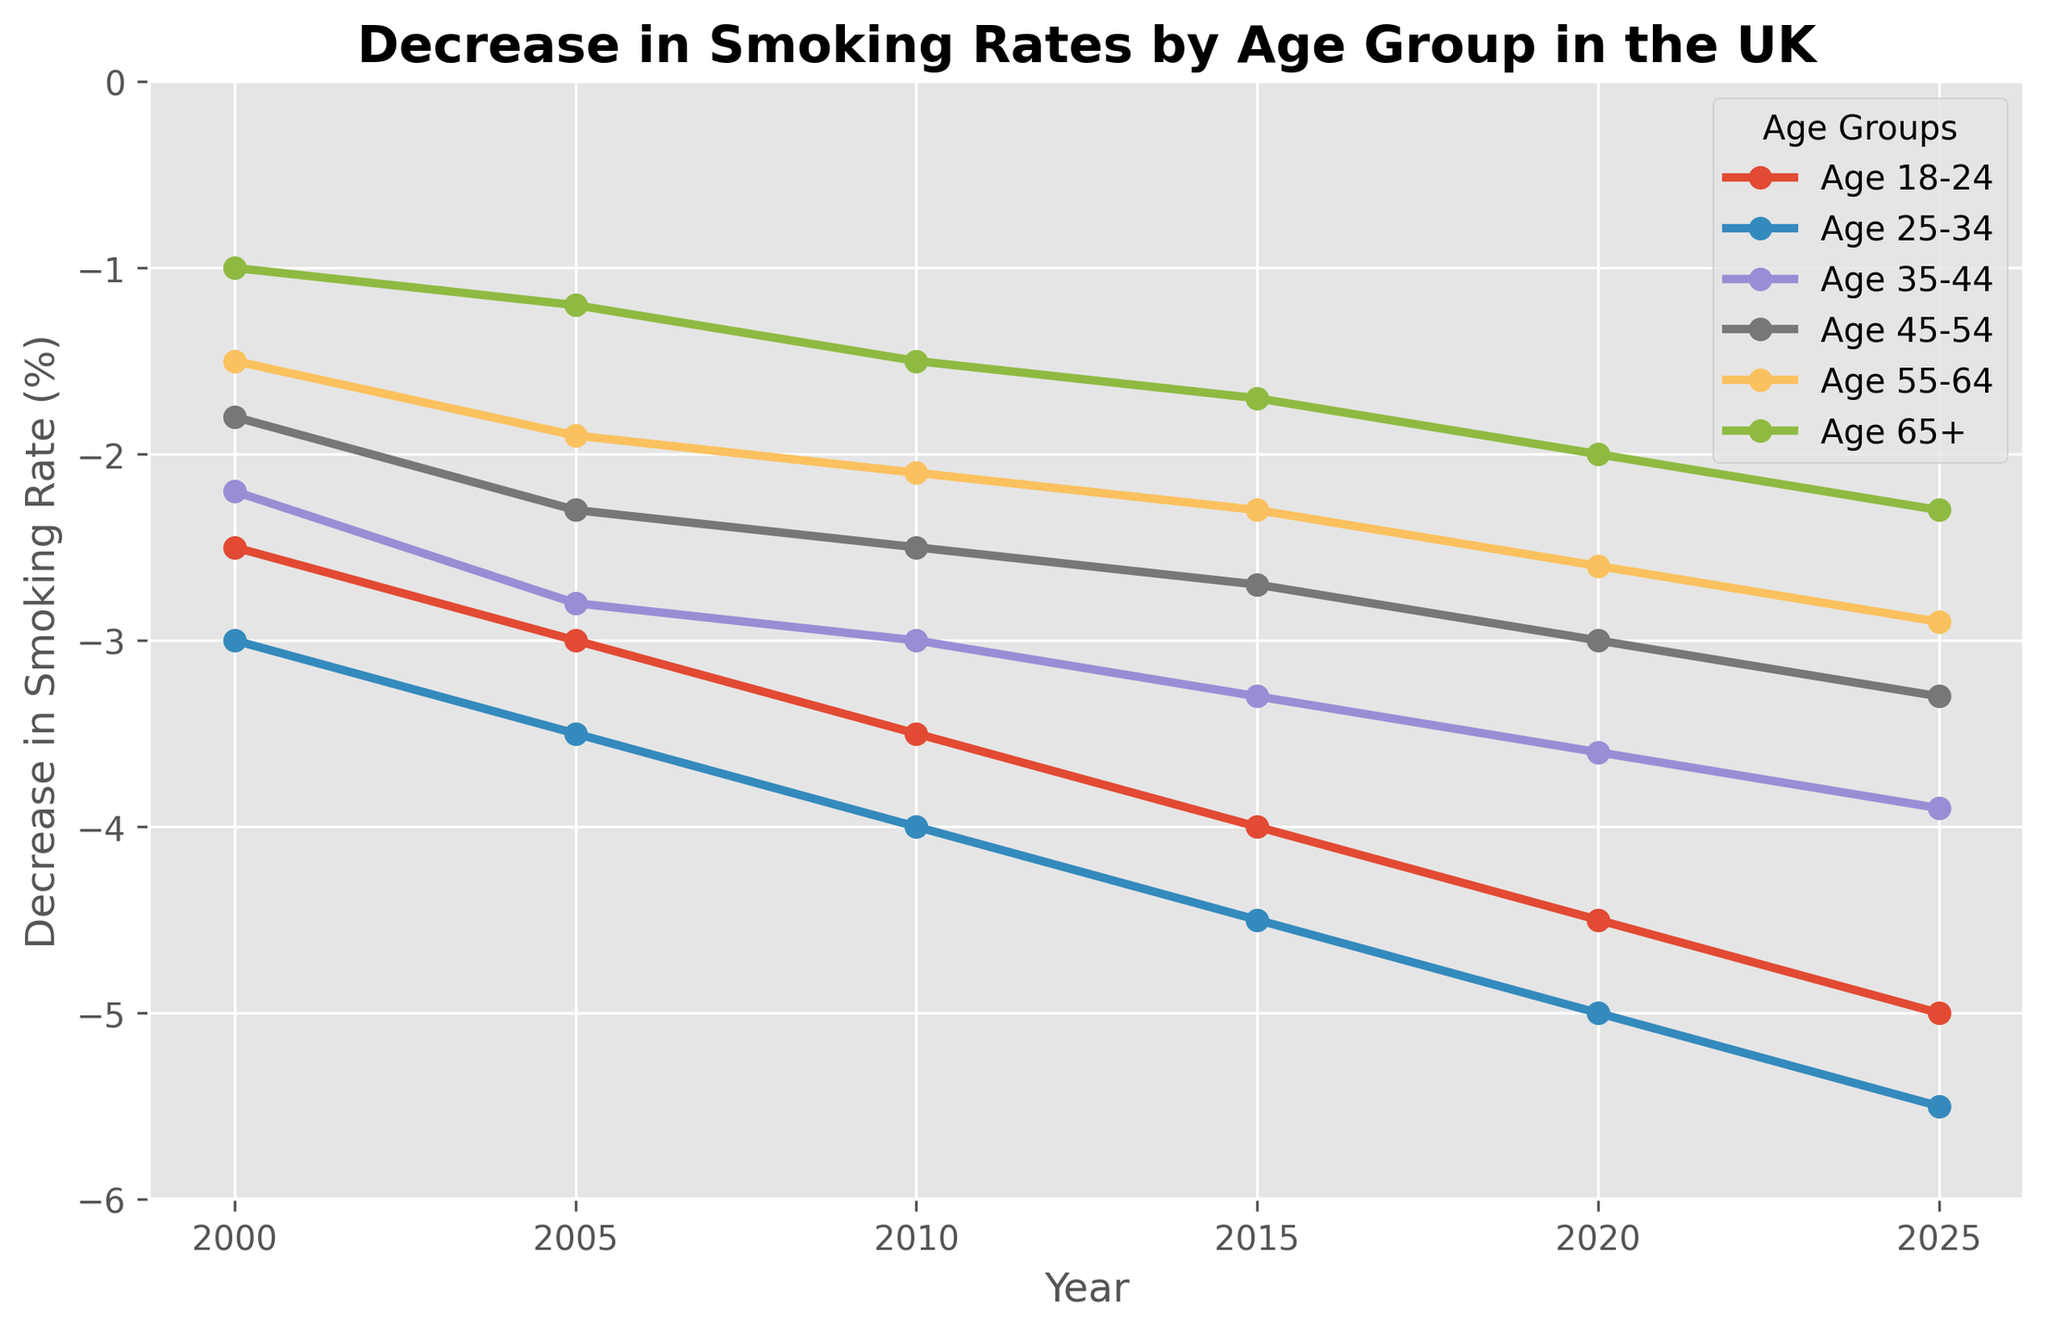What is the general trend in the decrease in smoking rates among the 18-24 age group from 2000 to 2025? The line for the 18-24 age group shows a consistent downward trend, starting at -2.5% in 2000 and reaching -5.0% in 2025, indicating a steady increase in the decrease rate over these years.
Answer: Steady downward trend Which age group had the largest decrease in smoking rates in 2020? By locating the year 2020 on the x-axis and looking at the lowest point, the 25-34 age group shows the largest decrease with a rate of -5.0%.
Answer: 25-34 age group How did the smoking rate decrease for the 65+ age group change between 2000 and 2025? The decrease rate for the 65+ age group in 2000 was -1.0% and it became -2.3% in 2025. This shows an increase of -1.3% in the decrease rate over these years.
Answer: Increase by -1.3% Between which age groups is the difference in the decrease in smoking rates the greatest in 2025? Observing the 2025 endpoints on the y-axis, the difference is greatest between the 18-24 (-5.0%) and 65+ (-2.3%) age groups, which is a difference of 2.7%.
Answer: 18-24 and 65+ Which age group consistently showed the smallest decrease in smoking rates across all years? By examining each year and identifying the line with the highest points, the 65+ age group consistently had the smallest decrease.
Answer: 65+ age group What was the average decrease in smoking rate for the 25-34 age group from 2000 to 2025? For the 25-34 age group: (-3.0 - 3.5 - 4.0 - 4.5 - 5.0 - 5.5) / 6 = (-25.5 / 6) = -4.25%. So the average decrease was -4.25%.
Answer: -4.25% In which year did the 35-44 age group reach a decrease in smoking rate of -3.3%? The line representing the 35-44 age group hits -3.3% in 2015 when identified along the y-axis.
Answer: 2015 Compare the decrease in smoking rates between the 45-54 and 55-64 age groups in 2005. Which group had a more significant decrease? In 2005, the 45-54 group had a decrease of -2.3% while the 55-64 group had -1.9%. Thus, the 45-54 group had a more significant decrease.
Answer: 45-54 age group 